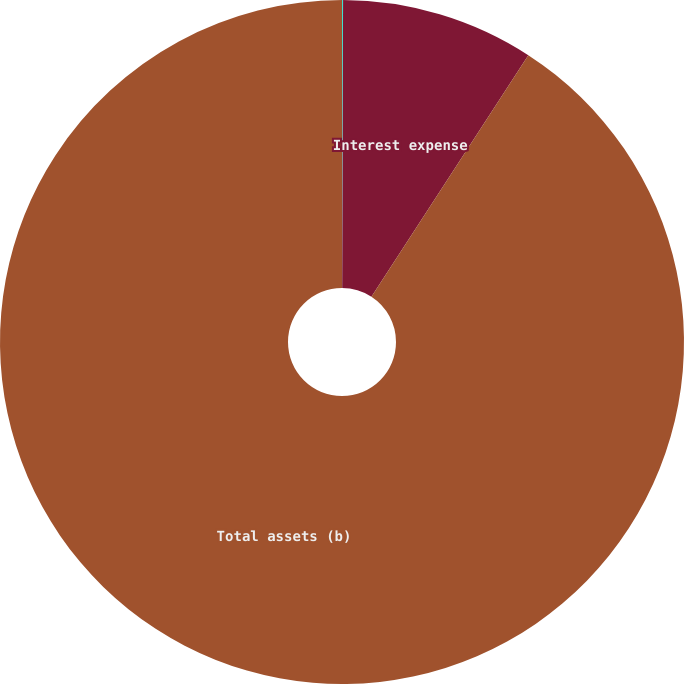<chart> <loc_0><loc_0><loc_500><loc_500><pie_chart><fcel>Interest and dividend income<fcel>Interest expense<fcel>Total assets (b)<nl><fcel>0.05%<fcel>9.12%<fcel>90.83%<nl></chart> 